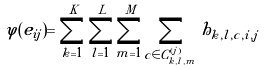Convert formula to latex. <formula><loc_0><loc_0><loc_500><loc_500>\varphi ( e _ { i j } ) = \sum _ { k = 1 } ^ { K } \sum _ { l = 1 } ^ { L } \sum _ { m = 1 } ^ { M } \sum _ { c \in C _ { k , l , m } ^ { ( j ) } } h _ { k , l , c , i , j }</formula> 